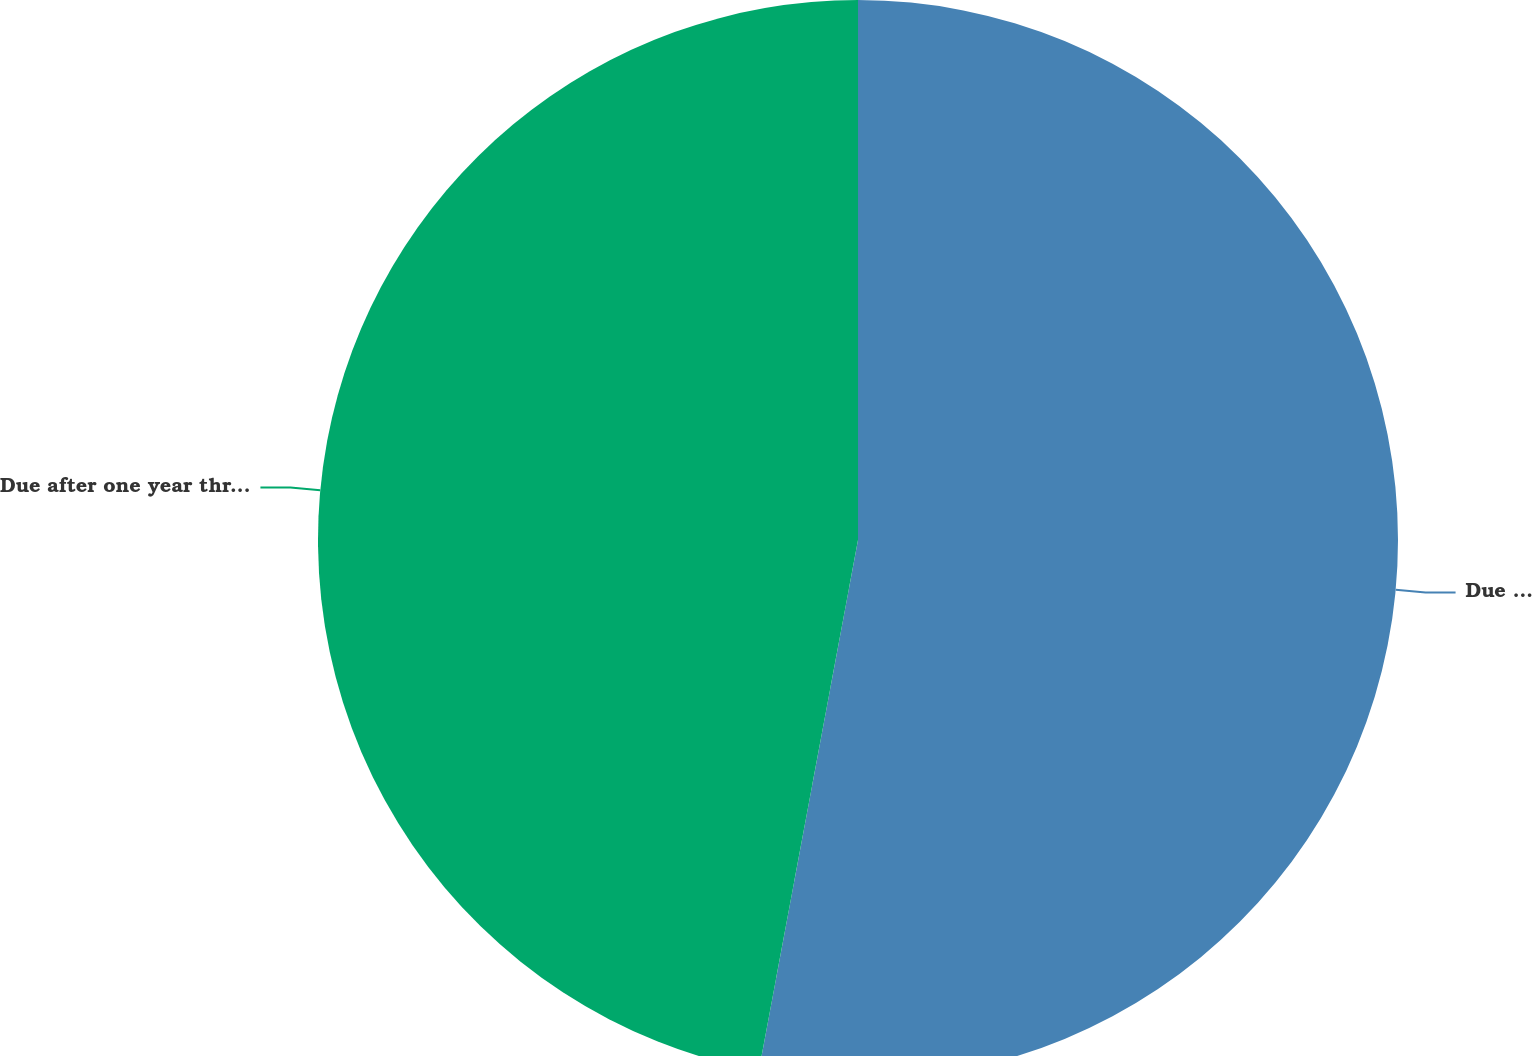<chart> <loc_0><loc_0><loc_500><loc_500><pie_chart><fcel>Due in one year or less<fcel>Due after one year through<nl><fcel>52.94%<fcel>47.06%<nl></chart> 